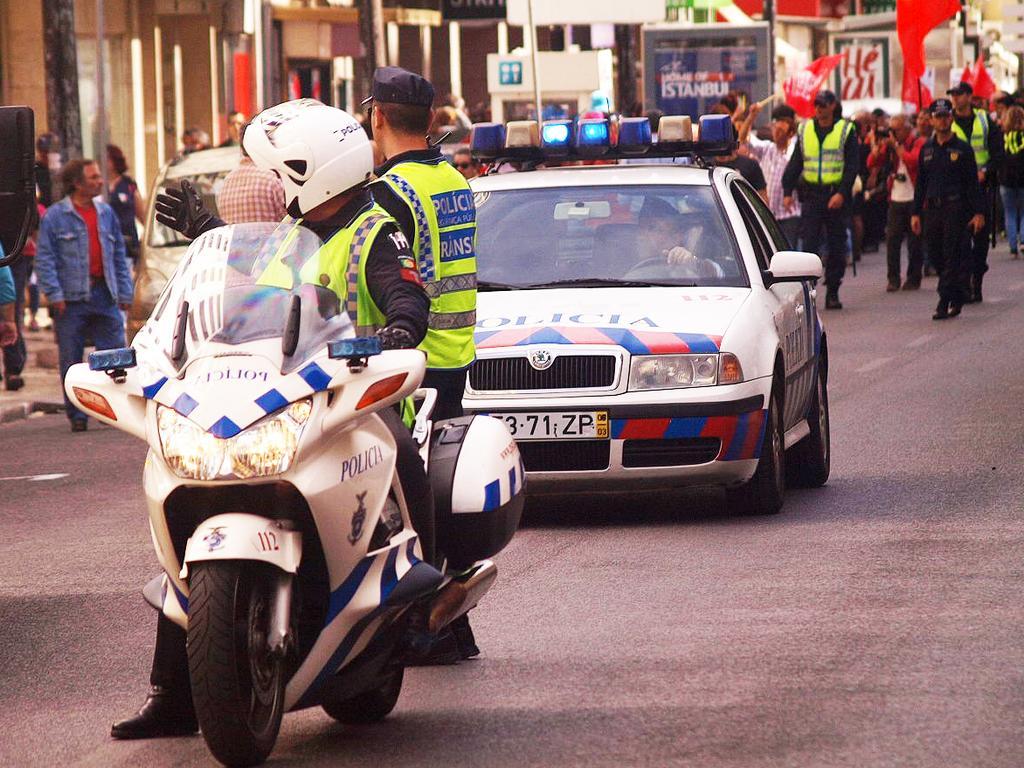Could you give a brief overview of what you see in this image? There is a police sitting on a bike and there is a police car behind him and there are group of people in the background. 